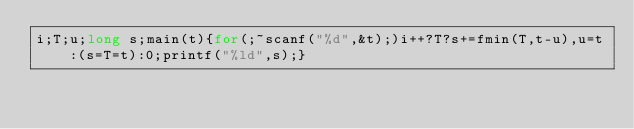<code> <loc_0><loc_0><loc_500><loc_500><_C_>i;T;u;long s;main(t){for(;~scanf("%d",&t);)i++?T?s+=fmin(T,t-u),u=t:(s=T=t):0;printf("%ld",s);}</code> 